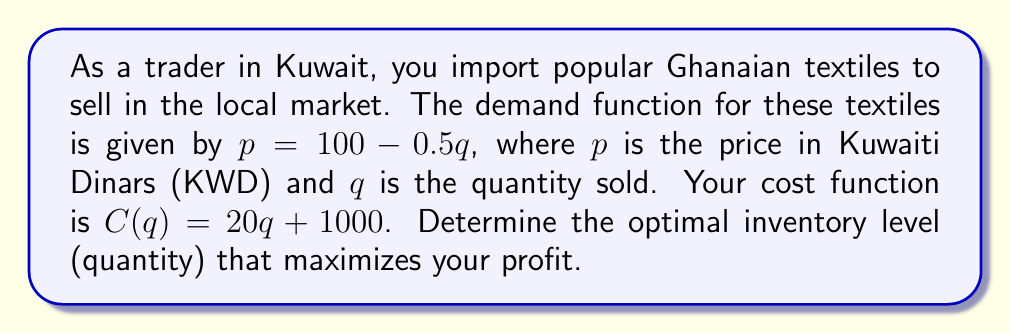What is the answer to this math problem? To solve this problem, we'll follow these steps:

1) First, let's define the profit function $P(q)$:
   $P(q) = \text{Revenue} - \text{Cost}$
   $P(q) = pq - C(q)$

2) Substitute the demand function into the profit function:
   $P(q) = (100 - 0.5q)q - (20q + 1000)$
   $P(q) = 100q - 0.5q^2 - 20q - 1000$
   $P(q) = -0.5q^2 + 80q - 1000$

3) To find the maximum profit, we need to find where the derivative of $P(q)$ equals zero:
   $\frac{dP}{dq} = -q + 80$

4) Set this equal to zero and solve for $q$:
   $-q + 80 = 0$
   $q = 80$

5) To confirm this is a maximum, we can check the second derivative:
   $\frac{d^2P}{dq^2} = -1$
   Since this is negative, we confirm that $q = 80$ gives a maximum.

6) Therefore, the optimal inventory level is 80 units.
Answer: 80 units 